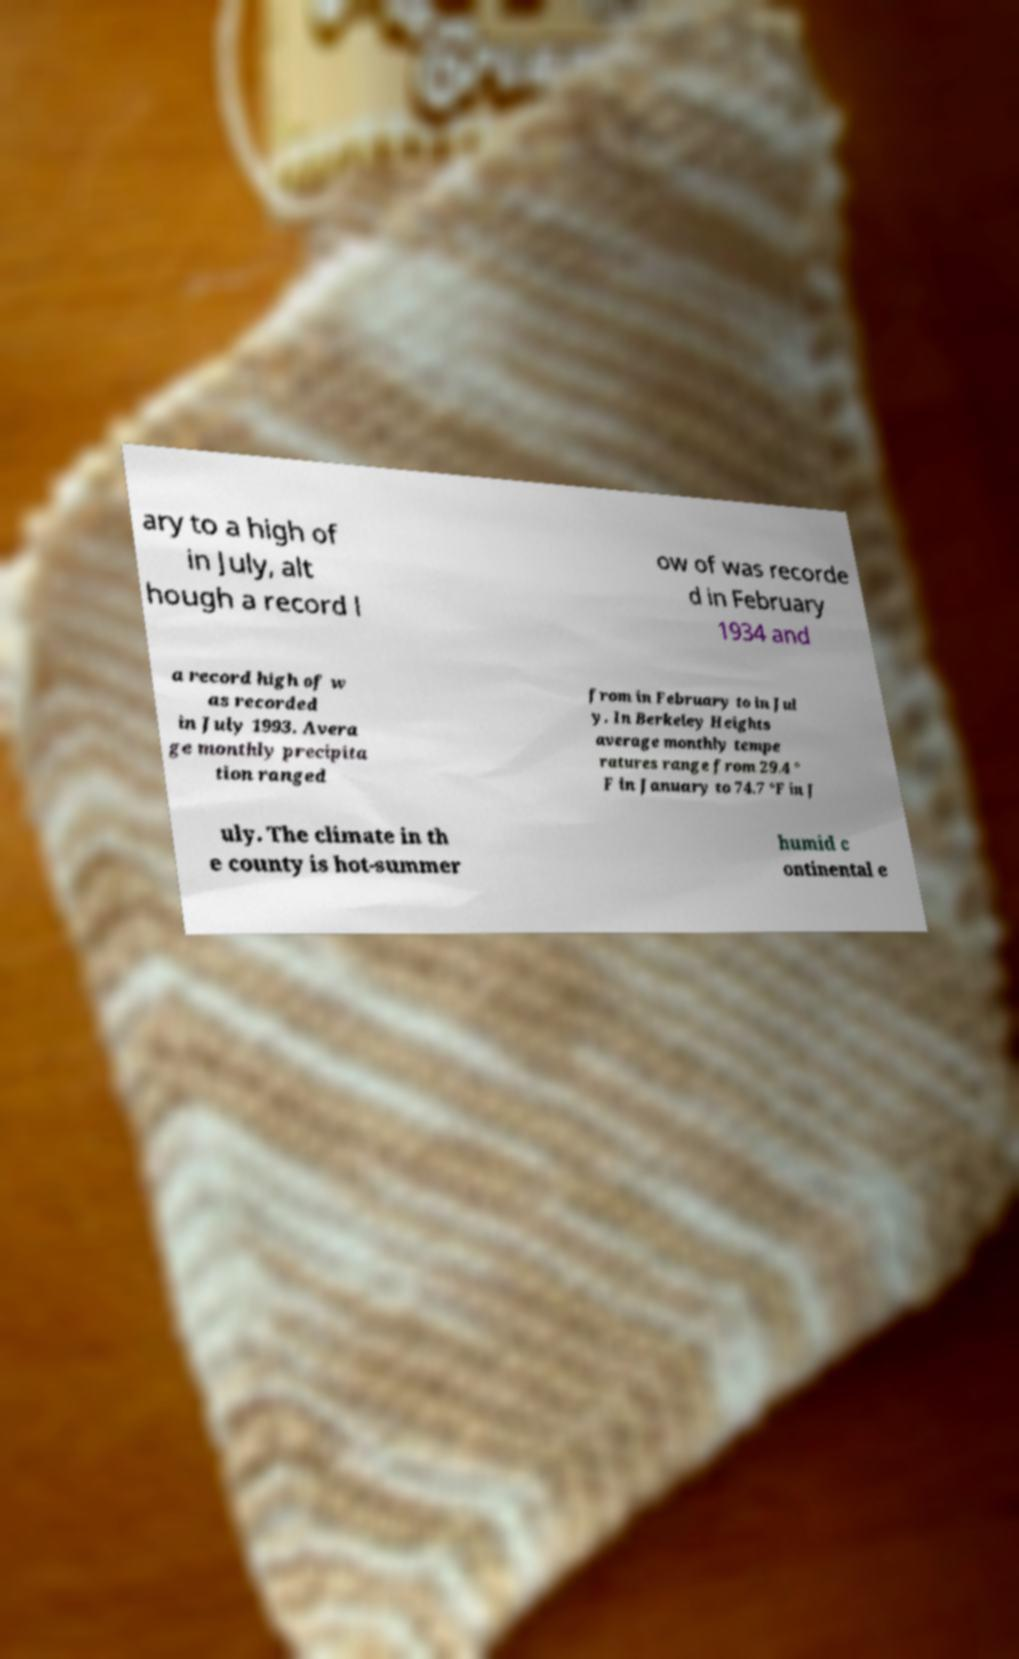Can you read and provide the text displayed in the image?This photo seems to have some interesting text. Can you extract and type it out for me? ary to a high of in July, alt hough a record l ow of was recorde d in February 1934 and a record high of w as recorded in July 1993. Avera ge monthly precipita tion ranged from in February to in Jul y. In Berkeley Heights average monthly tempe ratures range from 29.4 ° F in January to 74.7 °F in J uly. The climate in th e county is hot-summer humid c ontinental e 